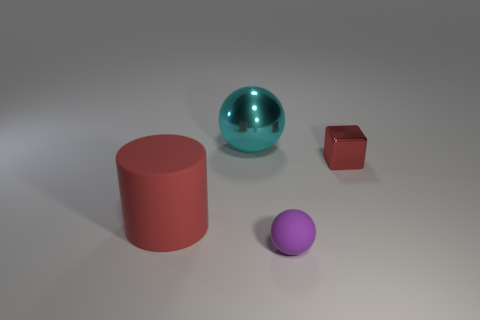Subtract all brown cubes. Subtract all gray spheres. How many cubes are left? 1 Add 4 cyan objects. How many objects exist? 8 Subtract all cylinders. How many objects are left? 3 Subtract 0 green spheres. How many objects are left? 4 Subtract all small rubber blocks. Subtract all purple rubber objects. How many objects are left? 3 Add 2 large metallic balls. How many large metallic balls are left? 3 Add 1 big red things. How many big red things exist? 2 